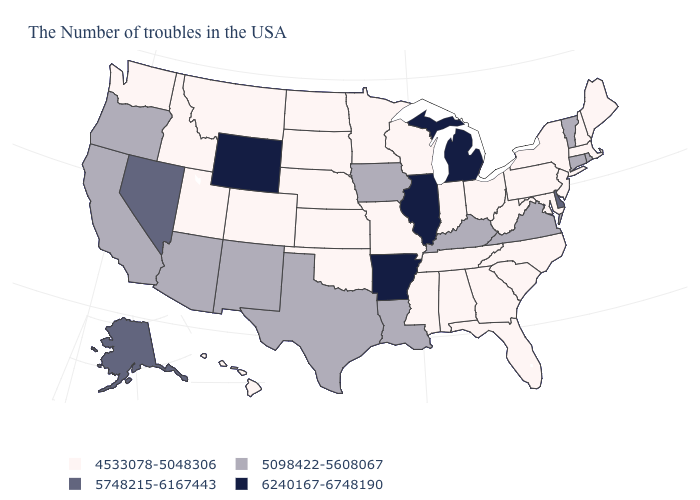Does New Mexico have the same value as Alaska?
Be succinct. No. What is the value of New Jersey?
Concise answer only. 4533078-5048306. What is the value of Massachusetts?
Quick response, please. 4533078-5048306. Which states have the lowest value in the USA?
Be succinct. Maine, Massachusetts, New Hampshire, New York, New Jersey, Maryland, Pennsylvania, North Carolina, South Carolina, West Virginia, Ohio, Florida, Georgia, Indiana, Alabama, Tennessee, Wisconsin, Mississippi, Missouri, Minnesota, Kansas, Nebraska, Oklahoma, South Dakota, North Dakota, Colorado, Utah, Montana, Idaho, Washington, Hawaii. What is the value of Tennessee?
Keep it brief. 4533078-5048306. Which states have the lowest value in the USA?
Quick response, please. Maine, Massachusetts, New Hampshire, New York, New Jersey, Maryland, Pennsylvania, North Carolina, South Carolina, West Virginia, Ohio, Florida, Georgia, Indiana, Alabama, Tennessee, Wisconsin, Mississippi, Missouri, Minnesota, Kansas, Nebraska, Oklahoma, South Dakota, North Dakota, Colorado, Utah, Montana, Idaho, Washington, Hawaii. Which states have the lowest value in the USA?
Answer briefly. Maine, Massachusetts, New Hampshire, New York, New Jersey, Maryland, Pennsylvania, North Carolina, South Carolina, West Virginia, Ohio, Florida, Georgia, Indiana, Alabama, Tennessee, Wisconsin, Mississippi, Missouri, Minnesota, Kansas, Nebraska, Oklahoma, South Dakota, North Dakota, Colorado, Utah, Montana, Idaho, Washington, Hawaii. Name the states that have a value in the range 4533078-5048306?
Short answer required. Maine, Massachusetts, New Hampshire, New York, New Jersey, Maryland, Pennsylvania, North Carolina, South Carolina, West Virginia, Ohio, Florida, Georgia, Indiana, Alabama, Tennessee, Wisconsin, Mississippi, Missouri, Minnesota, Kansas, Nebraska, Oklahoma, South Dakota, North Dakota, Colorado, Utah, Montana, Idaho, Washington, Hawaii. Is the legend a continuous bar?
Be succinct. No. Name the states that have a value in the range 4533078-5048306?
Keep it brief. Maine, Massachusetts, New Hampshire, New York, New Jersey, Maryland, Pennsylvania, North Carolina, South Carolina, West Virginia, Ohio, Florida, Georgia, Indiana, Alabama, Tennessee, Wisconsin, Mississippi, Missouri, Minnesota, Kansas, Nebraska, Oklahoma, South Dakota, North Dakota, Colorado, Utah, Montana, Idaho, Washington, Hawaii. Name the states that have a value in the range 5098422-5608067?
Be succinct. Rhode Island, Vermont, Connecticut, Virginia, Kentucky, Louisiana, Iowa, Texas, New Mexico, Arizona, California, Oregon. What is the highest value in the USA?
Concise answer only. 6240167-6748190. Name the states that have a value in the range 5098422-5608067?
Answer briefly. Rhode Island, Vermont, Connecticut, Virginia, Kentucky, Louisiana, Iowa, Texas, New Mexico, Arizona, California, Oregon. Is the legend a continuous bar?
Short answer required. No. Does Alabama have the highest value in the USA?
Short answer required. No. 